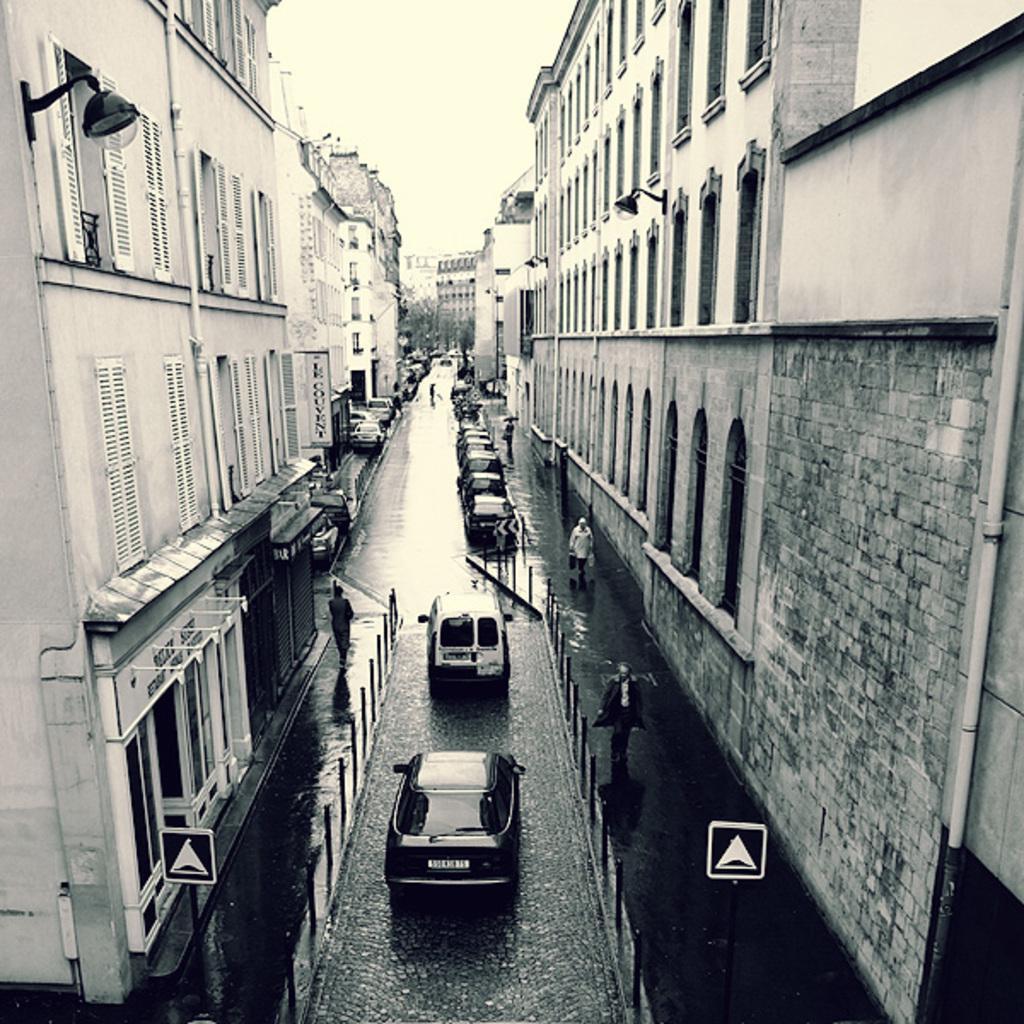Can you describe this image briefly? This is a black and white pic. We can see vehicles on the road, windows, few persons are walking on the road, buildings, lights on the walls, doors, sign board poles and sky. 